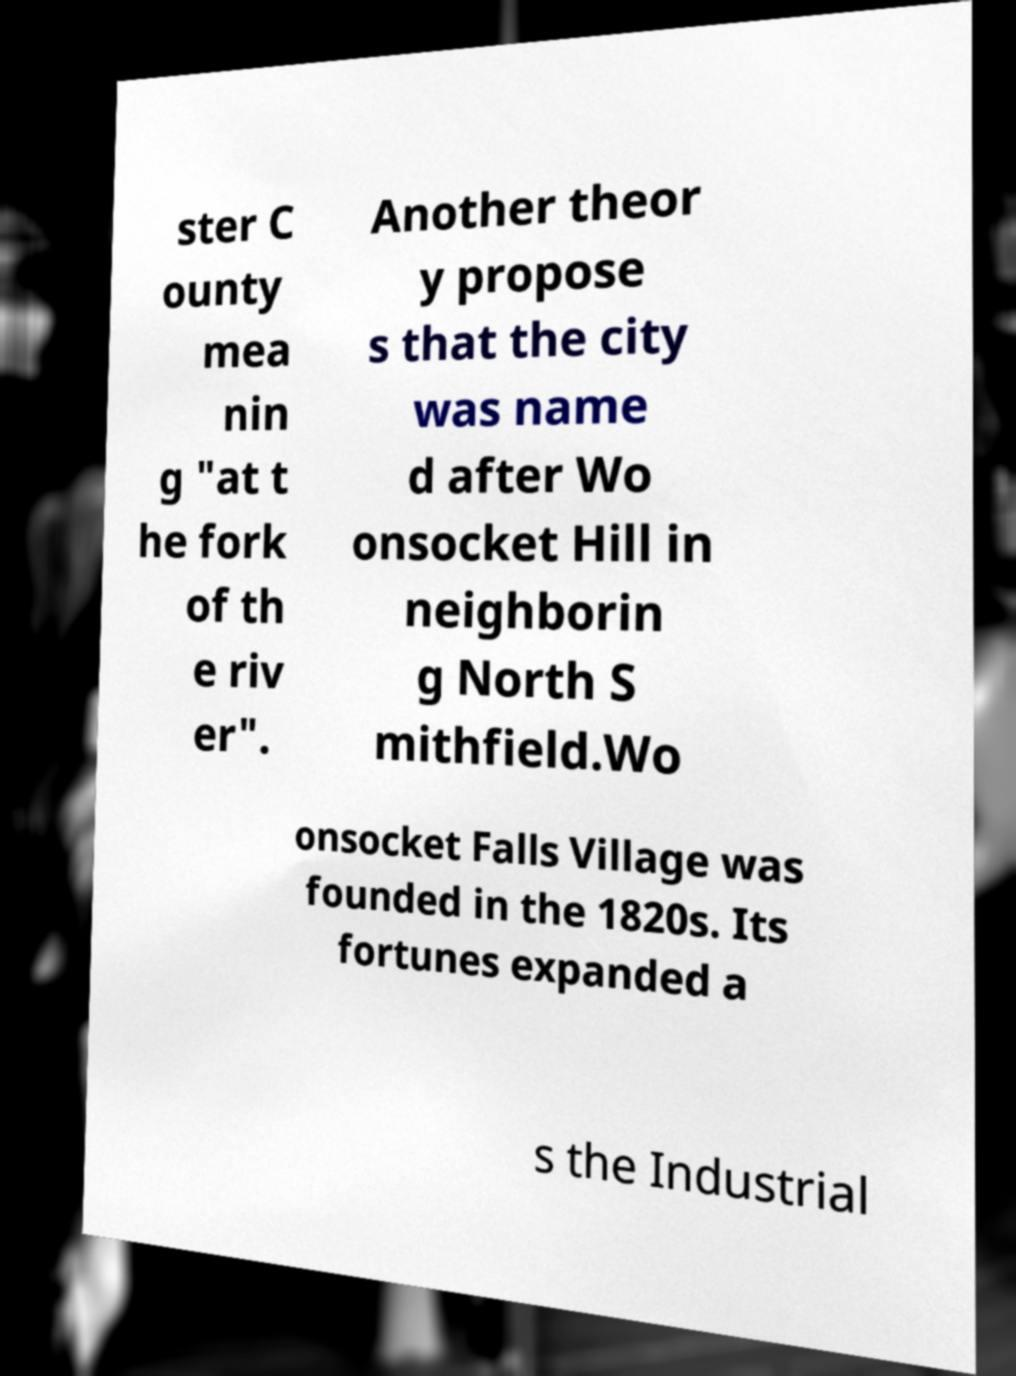Can you read and provide the text displayed in the image?This photo seems to have some interesting text. Can you extract and type it out for me? ster C ounty mea nin g "at t he fork of th e riv er". Another theor y propose s that the city was name d after Wo onsocket Hill in neighborin g North S mithfield.Wo onsocket Falls Village was founded in the 1820s. Its fortunes expanded a s the Industrial 